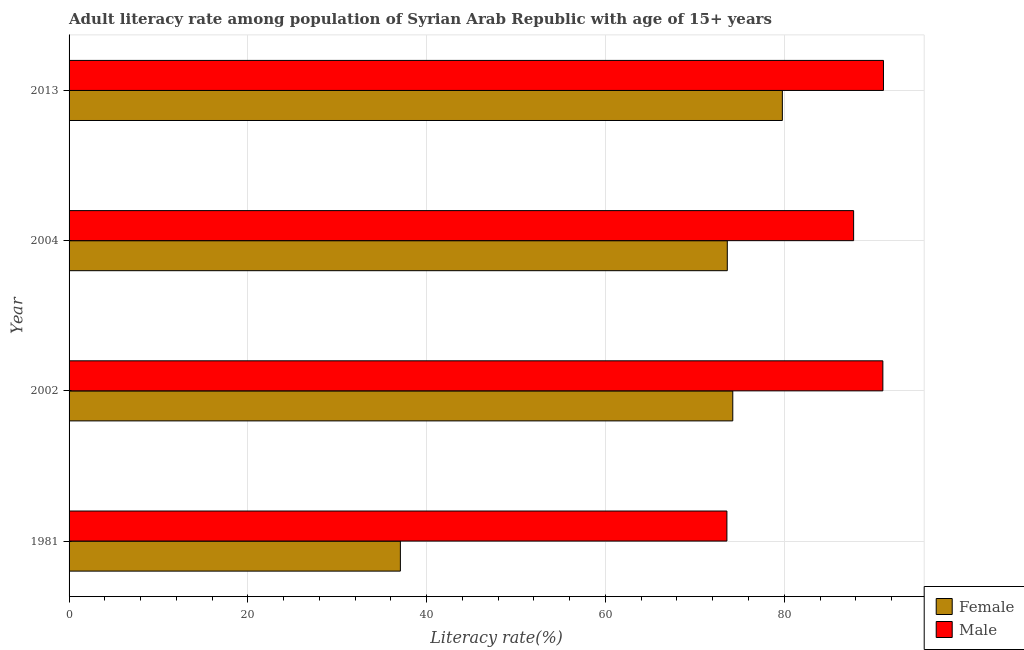How many groups of bars are there?
Give a very brief answer. 4. Are the number of bars on each tick of the Y-axis equal?
Make the answer very short. Yes. How many bars are there on the 2nd tick from the top?
Ensure brevity in your answer.  2. What is the male adult literacy rate in 2013?
Offer a terse response. 91.1. Across all years, what is the maximum female adult literacy rate?
Offer a terse response. 79.79. Across all years, what is the minimum male adult literacy rate?
Keep it short and to the point. 73.58. In which year was the female adult literacy rate maximum?
Keep it short and to the point. 2013. In which year was the male adult literacy rate minimum?
Your answer should be compact. 1981. What is the total female adult literacy rate in the graph?
Keep it short and to the point. 264.71. What is the difference between the female adult literacy rate in 1981 and that in 2004?
Give a very brief answer. -36.57. What is the difference between the male adult literacy rate in 1981 and the female adult literacy rate in 2013?
Your answer should be compact. -6.2. What is the average female adult literacy rate per year?
Offer a terse response. 66.18. In the year 1981, what is the difference between the female adult literacy rate and male adult literacy rate?
Give a very brief answer. -36.52. In how many years, is the female adult literacy rate greater than 60 %?
Make the answer very short. 3. What is the ratio of the male adult literacy rate in 1981 to that in 2002?
Offer a terse response. 0.81. Is the male adult literacy rate in 2002 less than that in 2004?
Provide a short and direct response. No. What is the difference between the highest and the second highest male adult literacy rate?
Offer a very short reply. 0.07. What is the difference between the highest and the lowest male adult literacy rate?
Ensure brevity in your answer.  17.51. In how many years, is the female adult literacy rate greater than the average female adult literacy rate taken over all years?
Ensure brevity in your answer.  3. What does the 2nd bar from the bottom in 2013 represents?
Offer a terse response. Male. How many bars are there?
Offer a very short reply. 8. Are all the bars in the graph horizontal?
Offer a very short reply. Yes. How many years are there in the graph?
Your answer should be compact. 4. Are the values on the major ticks of X-axis written in scientific E-notation?
Keep it short and to the point. No. Does the graph contain grids?
Give a very brief answer. Yes. How many legend labels are there?
Your response must be concise. 2. What is the title of the graph?
Your response must be concise. Adult literacy rate among population of Syrian Arab Republic with age of 15+ years. Does "Primary school" appear as one of the legend labels in the graph?
Give a very brief answer. No. What is the label or title of the X-axis?
Provide a short and direct response. Literacy rate(%). What is the Literacy rate(%) in Female in 1981?
Ensure brevity in your answer.  37.06. What is the Literacy rate(%) in Male in 1981?
Make the answer very short. 73.58. What is the Literacy rate(%) of Female in 2002?
Offer a very short reply. 74.24. What is the Literacy rate(%) of Male in 2002?
Provide a succinct answer. 91.03. What is the Literacy rate(%) in Female in 2004?
Keep it short and to the point. 73.63. What is the Literacy rate(%) of Male in 2004?
Give a very brief answer. 87.76. What is the Literacy rate(%) of Female in 2013?
Your answer should be very brief. 79.79. What is the Literacy rate(%) of Male in 2013?
Provide a succinct answer. 91.1. Across all years, what is the maximum Literacy rate(%) in Female?
Give a very brief answer. 79.79. Across all years, what is the maximum Literacy rate(%) in Male?
Provide a short and direct response. 91.1. Across all years, what is the minimum Literacy rate(%) of Female?
Offer a very short reply. 37.06. Across all years, what is the minimum Literacy rate(%) in Male?
Your answer should be very brief. 73.58. What is the total Literacy rate(%) in Female in the graph?
Give a very brief answer. 264.71. What is the total Literacy rate(%) of Male in the graph?
Your answer should be very brief. 343.47. What is the difference between the Literacy rate(%) of Female in 1981 and that in 2002?
Your answer should be compact. -37.18. What is the difference between the Literacy rate(%) of Male in 1981 and that in 2002?
Offer a very short reply. -17.44. What is the difference between the Literacy rate(%) in Female in 1981 and that in 2004?
Ensure brevity in your answer.  -36.57. What is the difference between the Literacy rate(%) in Male in 1981 and that in 2004?
Keep it short and to the point. -14.17. What is the difference between the Literacy rate(%) in Female in 1981 and that in 2013?
Your answer should be very brief. -42.73. What is the difference between the Literacy rate(%) of Male in 1981 and that in 2013?
Offer a terse response. -17.51. What is the difference between the Literacy rate(%) of Female in 2002 and that in 2004?
Your answer should be very brief. 0.61. What is the difference between the Literacy rate(%) of Male in 2002 and that in 2004?
Make the answer very short. 3.27. What is the difference between the Literacy rate(%) in Female in 2002 and that in 2013?
Make the answer very short. -5.55. What is the difference between the Literacy rate(%) of Male in 2002 and that in 2013?
Provide a short and direct response. -0.07. What is the difference between the Literacy rate(%) in Female in 2004 and that in 2013?
Your answer should be compact. -6.16. What is the difference between the Literacy rate(%) in Male in 2004 and that in 2013?
Your response must be concise. -3.34. What is the difference between the Literacy rate(%) in Female in 1981 and the Literacy rate(%) in Male in 2002?
Provide a succinct answer. -53.97. What is the difference between the Literacy rate(%) of Female in 1981 and the Literacy rate(%) of Male in 2004?
Your response must be concise. -50.7. What is the difference between the Literacy rate(%) in Female in 1981 and the Literacy rate(%) in Male in 2013?
Ensure brevity in your answer.  -54.04. What is the difference between the Literacy rate(%) of Female in 2002 and the Literacy rate(%) of Male in 2004?
Your answer should be very brief. -13.52. What is the difference between the Literacy rate(%) in Female in 2002 and the Literacy rate(%) in Male in 2013?
Your response must be concise. -16.86. What is the difference between the Literacy rate(%) in Female in 2004 and the Literacy rate(%) in Male in 2013?
Provide a succinct answer. -17.47. What is the average Literacy rate(%) of Female per year?
Make the answer very short. 66.18. What is the average Literacy rate(%) in Male per year?
Give a very brief answer. 85.87. In the year 1981, what is the difference between the Literacy rate(%) of Female and Literacy rate(%) of Male?
Provide a short and direct response. -36.53. In the year 2002, what is the difference between the Literacy rate(%) of Female and Literacy rate(%) of Male?
Give a very brief answer. -16.79. In the year 2004, what is the difference between the Literacy rate(%) in Female and Literacy rate(%) in Male?
Your answer should be very brief. -14.13. In the year 2013, what is the difference between the Literacy rate(%) of Female and Literacy rate(%) of Male?
Make the answer very short. -11.31. What is the ratio of the Literacy rate(%) of Female in 1981 to that in 2002?
Provide a short and direct response. 0.5. What is the ratio of the Literacy rate(%) of Male in 1981 to that in 2002?
Make the answer very short. 0.81. What is the ratio of the Literacy rate(%) in Female in 1981 to that in 2004?
Your answer should be very brief. 0.5. What is the ratio of the Literacy rate(%) of Male in 1981 to that in 2004?
Your answer should be very brief. 0.84. What is the ratio of the Literacy rate(%) of Female in 1981 to that in 2013?
Provide a short and direct response. 0.46. What is the ratio of the Literacy rate(%) of Male in 1981 to that in 2013?
Offer a very short reply. 0.81. What is the ratio of the Literacy rate(%) of Female in 2002 to that in 2004?
Give a very brief answer. 1.01. What is the ratio of the Literacy rate(%) of Male in 2002 to that in 2004?
Give a very brief answer. 1.04. What is the ratio of the Literacy rate(%) in Female in 2002 to that in 2013?
Provide a short and direct response. 0.93. What is the ratio of the Literacy rate(%) in Female in 2004 to that in 2013?
Your answer should be very brief. 0.92. What is the ratio of the Literacy rate(%) in Male in 2004 to that in 2013?
Your answer should be very brief. 0.96. What is the difference between the highest and the second highest Literacy rate(%) of Female?
Your answer should be very brief. 5.55. What is the difference between the highest and the second highest Literacy rate(%) in Male?
Your response must be concise. 0.07. What is the difference between the highest and the lowest Literacy rate(%) of Female?
Make the answer very short. 42.73. What is the difference between the highest and the lowest Literacy rate(%) in Male?
Provide a short and direct response. 17.51. 